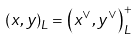<formula> <loc_0><loc_0><loc_500><loc_500>\left ( x , y \right ) _ { L } = \left ( x ^ { \vee } , y ^ { \vee } \right ) _ { L } ^ { + }</formula> 